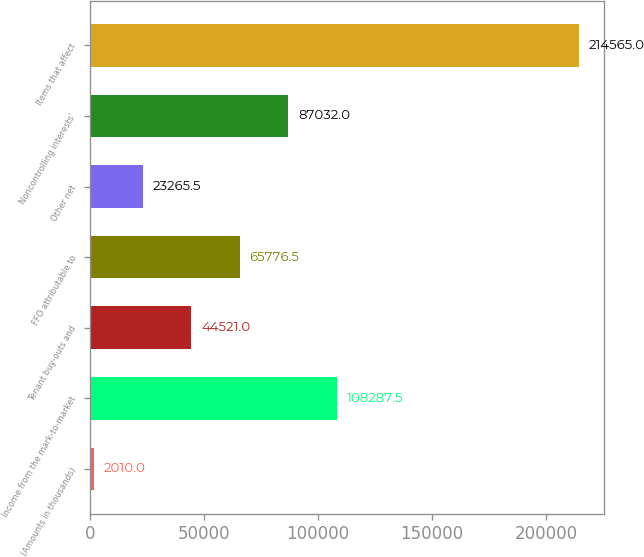Convert chart to OTSL. <chart><loc_0><loc_0><loc_500><loc_500><bar_chart><fcel>(Amounts in thousands)<fcel>Income from the mark-to-market<fcel>Tenant buy-outs and<fcel>FFO attributable to<fcel>Other net<fcel>Noncontrolling interests'<fcel>Items that affect<nl><fcel>2010<fcel>108288<fcel>44521<fcel>65776.5<fcel>23265.5<fcel>87032<fcel>214565<nl></chart> 